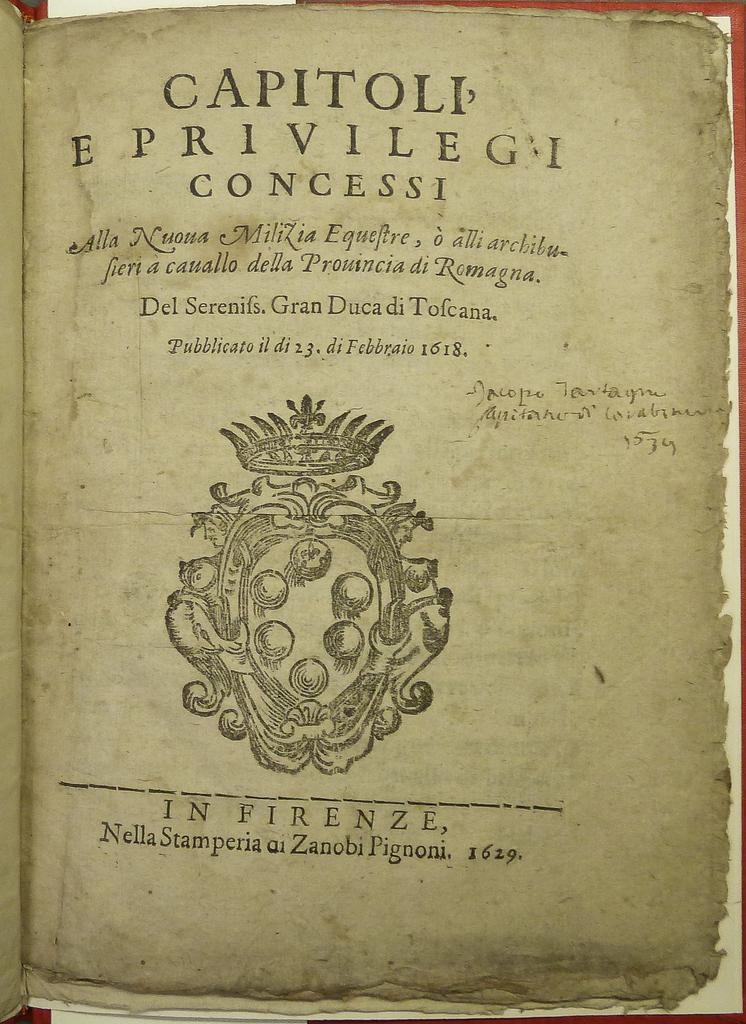<image>
Create a compact narrative representing the image presented. Book page with the words "Capitoli Eprivilegi" near the top. 